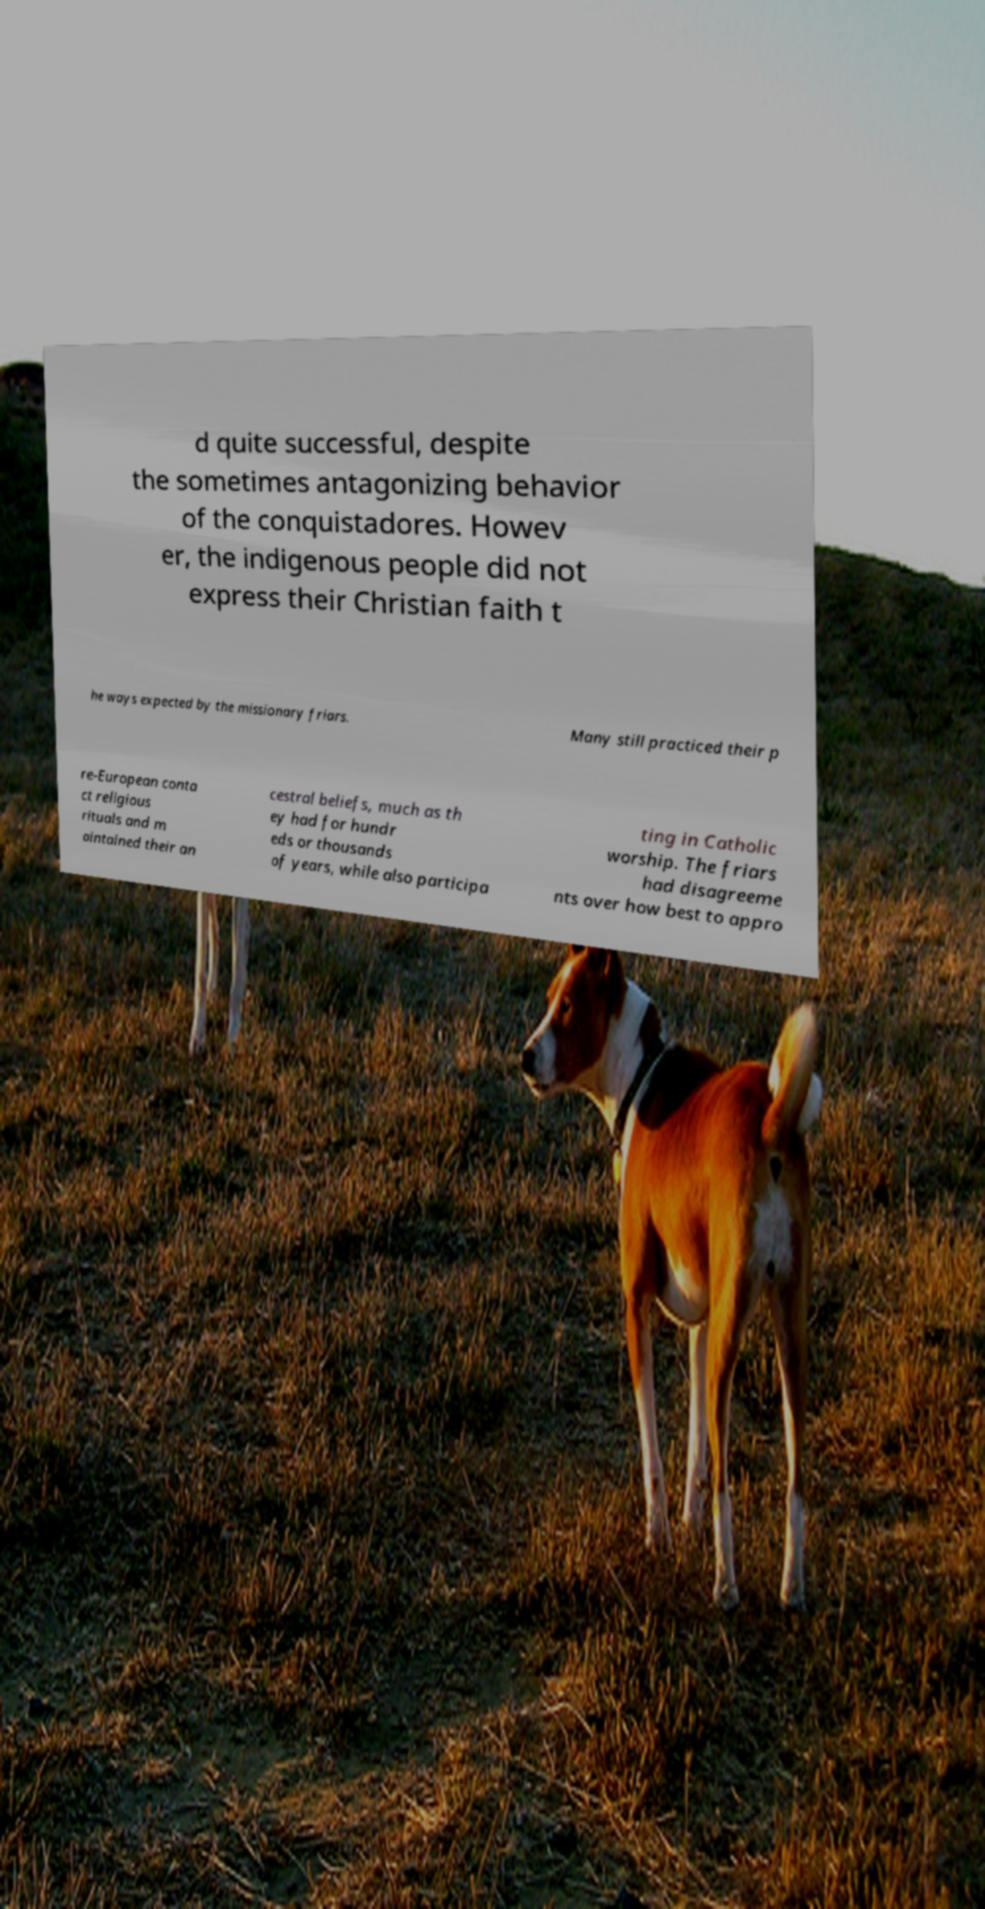Can you read and provide the text displayed in the image?This photo seems to have some interesting text. Can you extract and type it out for me? d quite successful, despite the sometimes antagonizing behavior of the conquistadores. Howev er, the indigenous people did not express their Christian faith t he ways expected by the missionary friars. Many still practiced their p re-European conta ct religious rituals and m aintained their an cestral beliefs, much as th ey had for hundr eds or thousands of years, while also participa ting in Catholic worship. The friars had disagreeme nts over how best to appro 